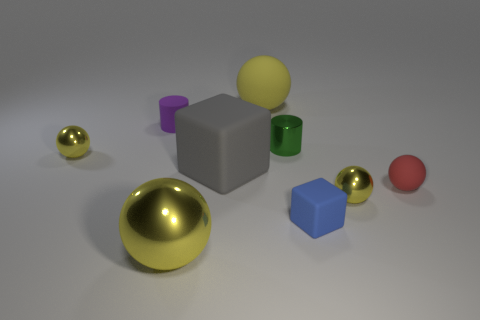How many yellow balls must be subtracted to get 2 yellow balls? 2 Subtract all green cylinders. How many yellow balls are left? 4 Subtract all red balls. How many balls are left? 4 Subtract all big matte balls. How many balls are left? 4 Subtract 1 spheres. How many spheres are left? 4 Subtract all purple spheres. Subtract all green cubes. How many spheres are left? 5 Add 1 big cylinders. How many objects exist? 10 Subtract all spheres. How many objects are left? 4 Subtract all yellow things. Subtract all big yellow rubber objects. How many objects are left? 4 Add 5 small shiny cylinders. How many small shiny cylinders are left? 6 